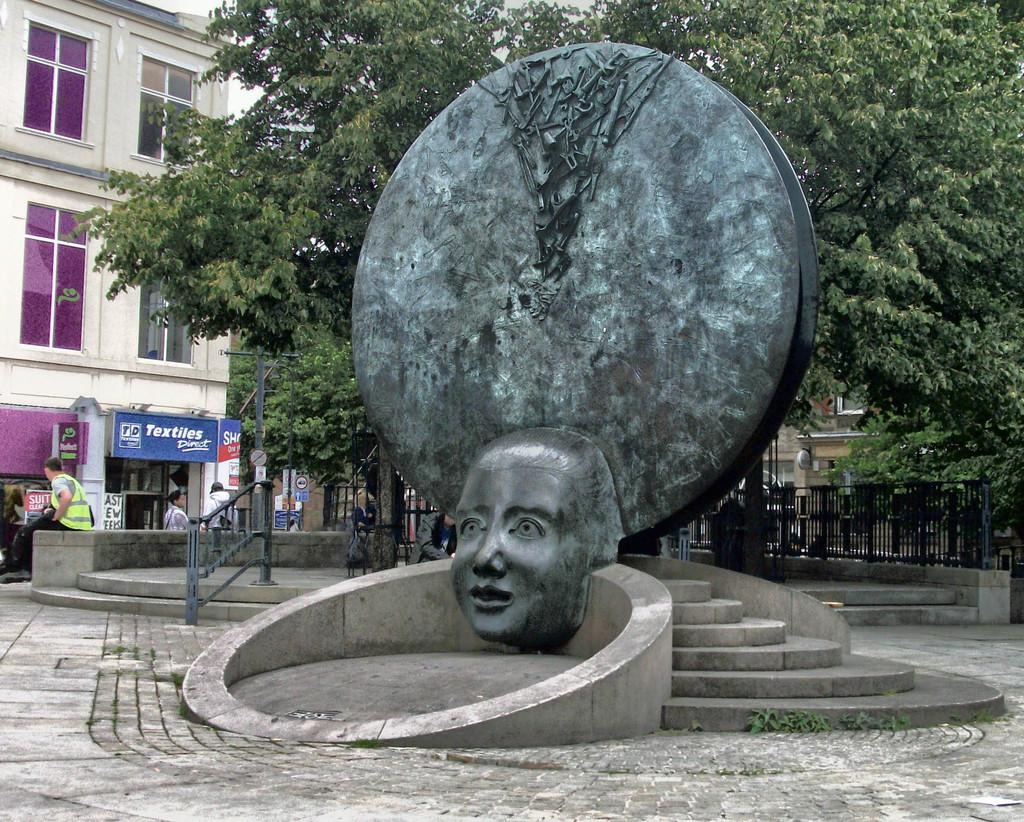What is the main subject in the center of the image? There is a statue in the center of the image. What architectural feature can be seen in the image? There are stairs in the image. What type of barrier is present in the image? There is a fence in the image. Can you describe the people in the image? There is a group of people in the image. What type of vegetation is visible in the image? There are trees in the image. What type of structure is present in the image? There is a building with windows in the image. What is written on the building? There is a name board on the building. How many chairs are visible in the image? There are no chairs present in the image. What fact can be learned about the statue from the image? The image does not provide any additional facts about the statue beyond its presence and location. 